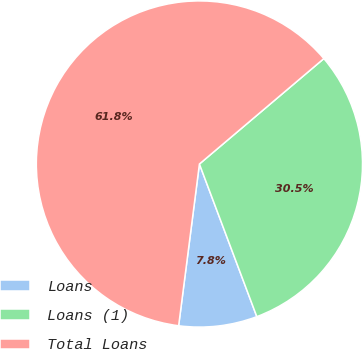Convert chart to OTSL. <chart><loc_0><loc_0><loc_500><loc_500><pie_chart><fcel>Loans<fcel>Loans (1)<fcel>Total Loans<nl><fcel>7.76%<fcel>30.46%<fcel>61.78%<nl></chart> 